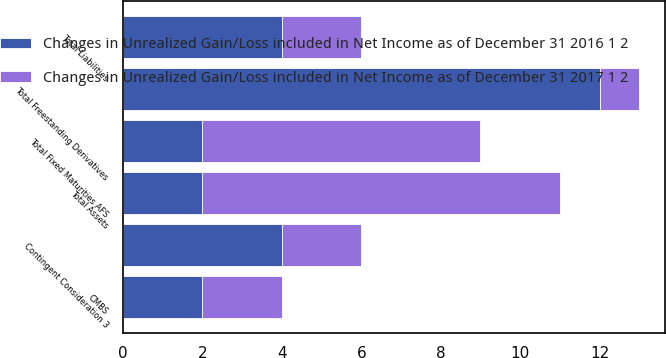Convert chart. <chart><loc_0><loc_0><loc_500><loc_500><stacked_bar_chart><ecel><fcel>CMBS<fcel>Total Fixed Maturities AFS<fcel>Total Freestanding Derivatives<fcel>Total Assets<fcel>Contingent Consideration 3<fcel>Total Liabilities<nl><fcel>Changes in Unrealized Gain/Loss included in Net Income as of December 31 2016 1 2<fcel>2<fcel>2<fcel>12<fcel>2<fcel>4<fcel>4<nl><fcel>Changes in Unrealized Gain/Loss included in Net Income as of December 31 2017 1 2<fcel>2<fcel>7<fcel>1<fcel>9<fcel>2<fcel>2<nl></chart> 